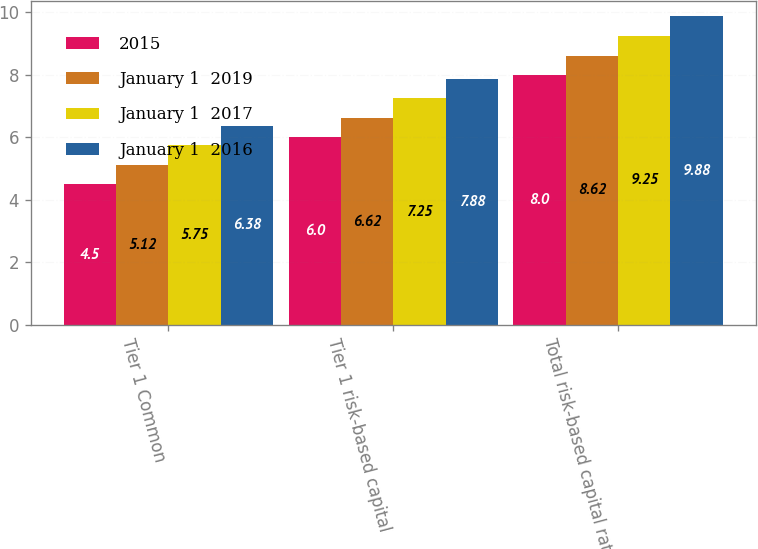<chart> <loc_0><loc_0><loc_500><loc_500><stacked_bar_chart><ecel><fcel>Tier 1 Common<fcel>Tier 1 risk-based capital<fcel>Total risk-based capital ratio<nl><fcel>2015<fcel>4.5<fcel>6<fcel>8<nl><fcel>January 1  2019<fcel>5.12<fcel>6.62<fcel>8.62<nl><fcel>January 1  2017<fcel>5.75<fcel>7.25<fcel>9.25<nl><fcel>January 1  2016<fcel>6.38<fcel>7.88<fcel>9.88<nl></chart> 